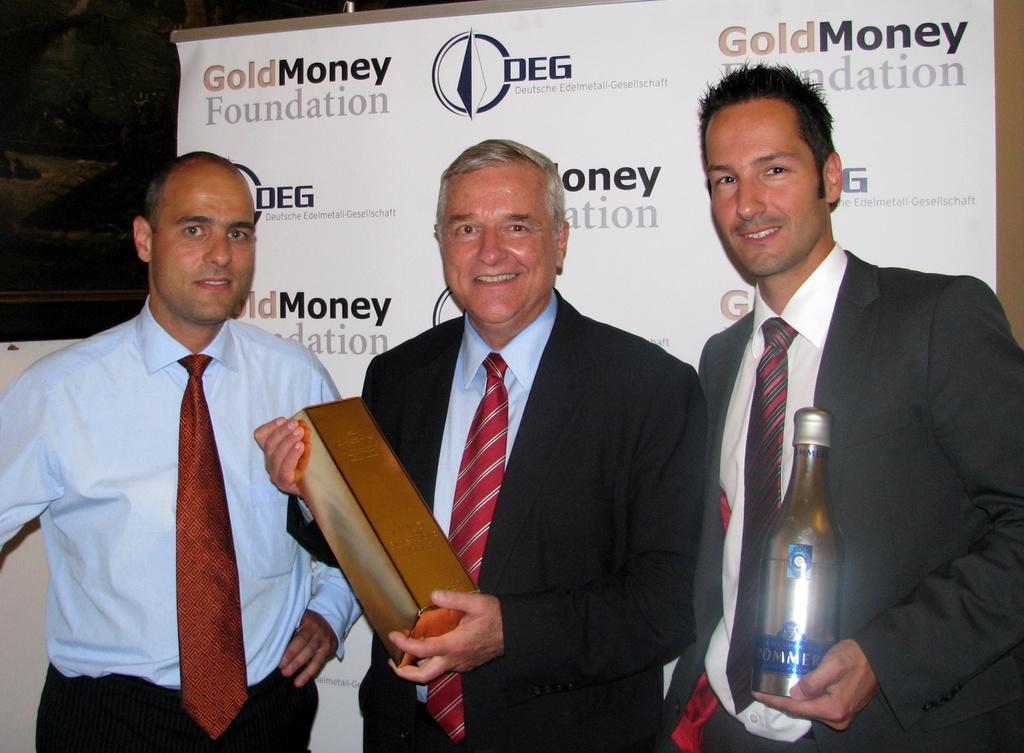How would you summarize this image in a sentence or two? In the middle of the image three persons are standing, smiling and holding some bottles. Behind them there is a banner. 